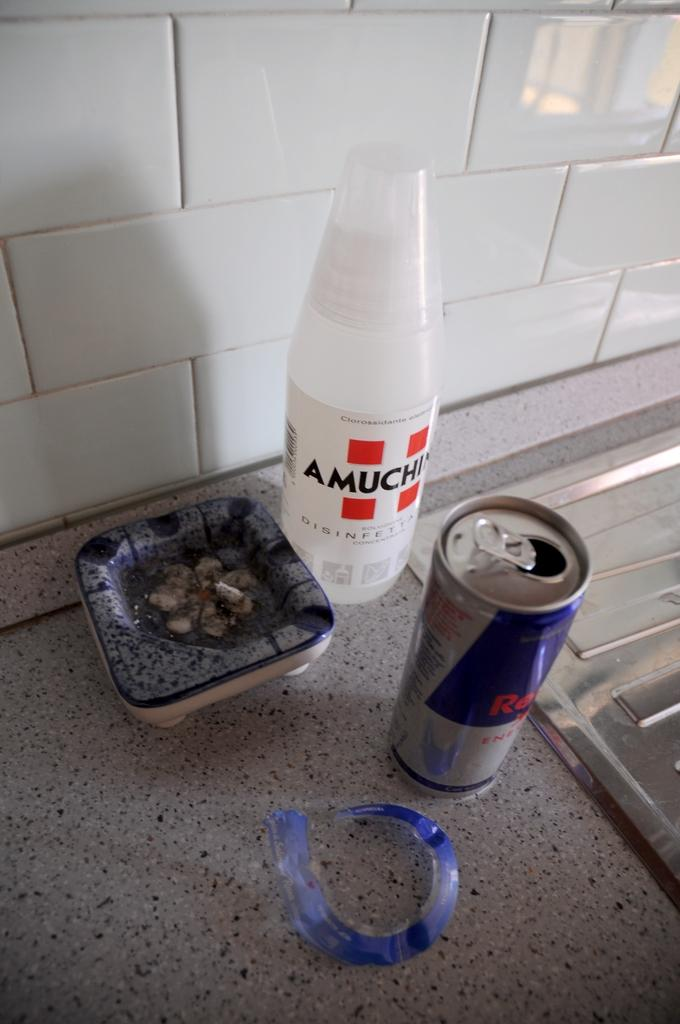<image>
Give a short and clear explanation of the subsequent image. An ashtray, a redbull can and a white amuchin bottle sitting on a counter. 